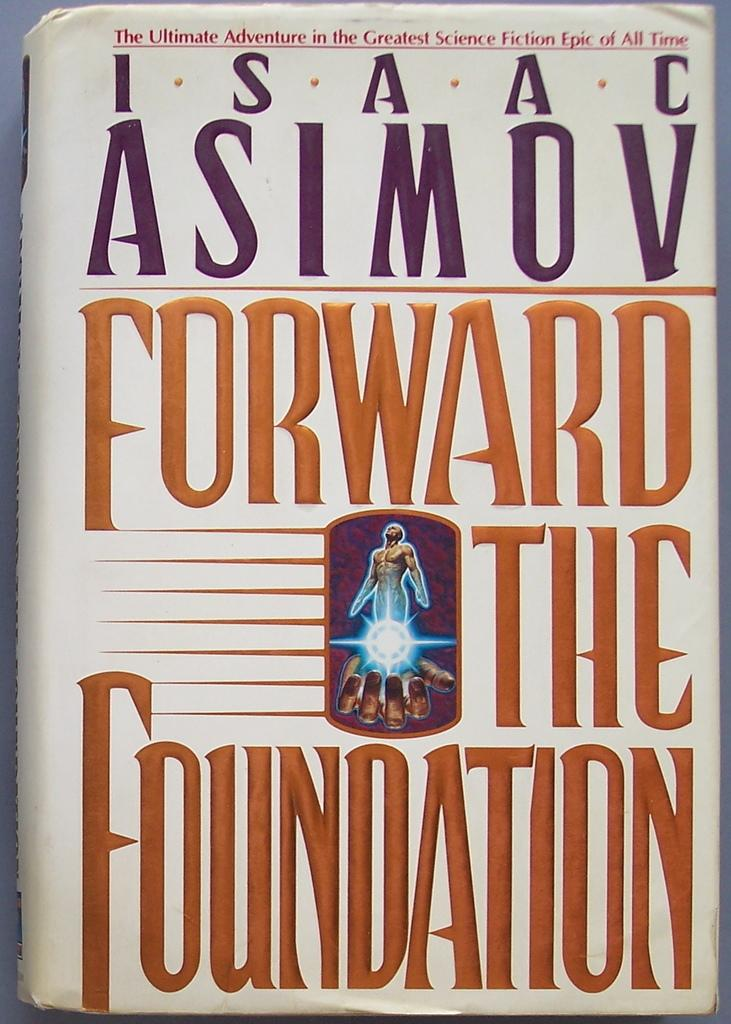What is the main subject in the center of the image? There is a book in the center of the image. Where is the book located? The book is on a table. What type of bomb is depicted on the book cover in the image? There is no bomb depicted on the book cover in the image; it is simply a book. What form does the pencil take in the image? There is no pencil present in the image. 